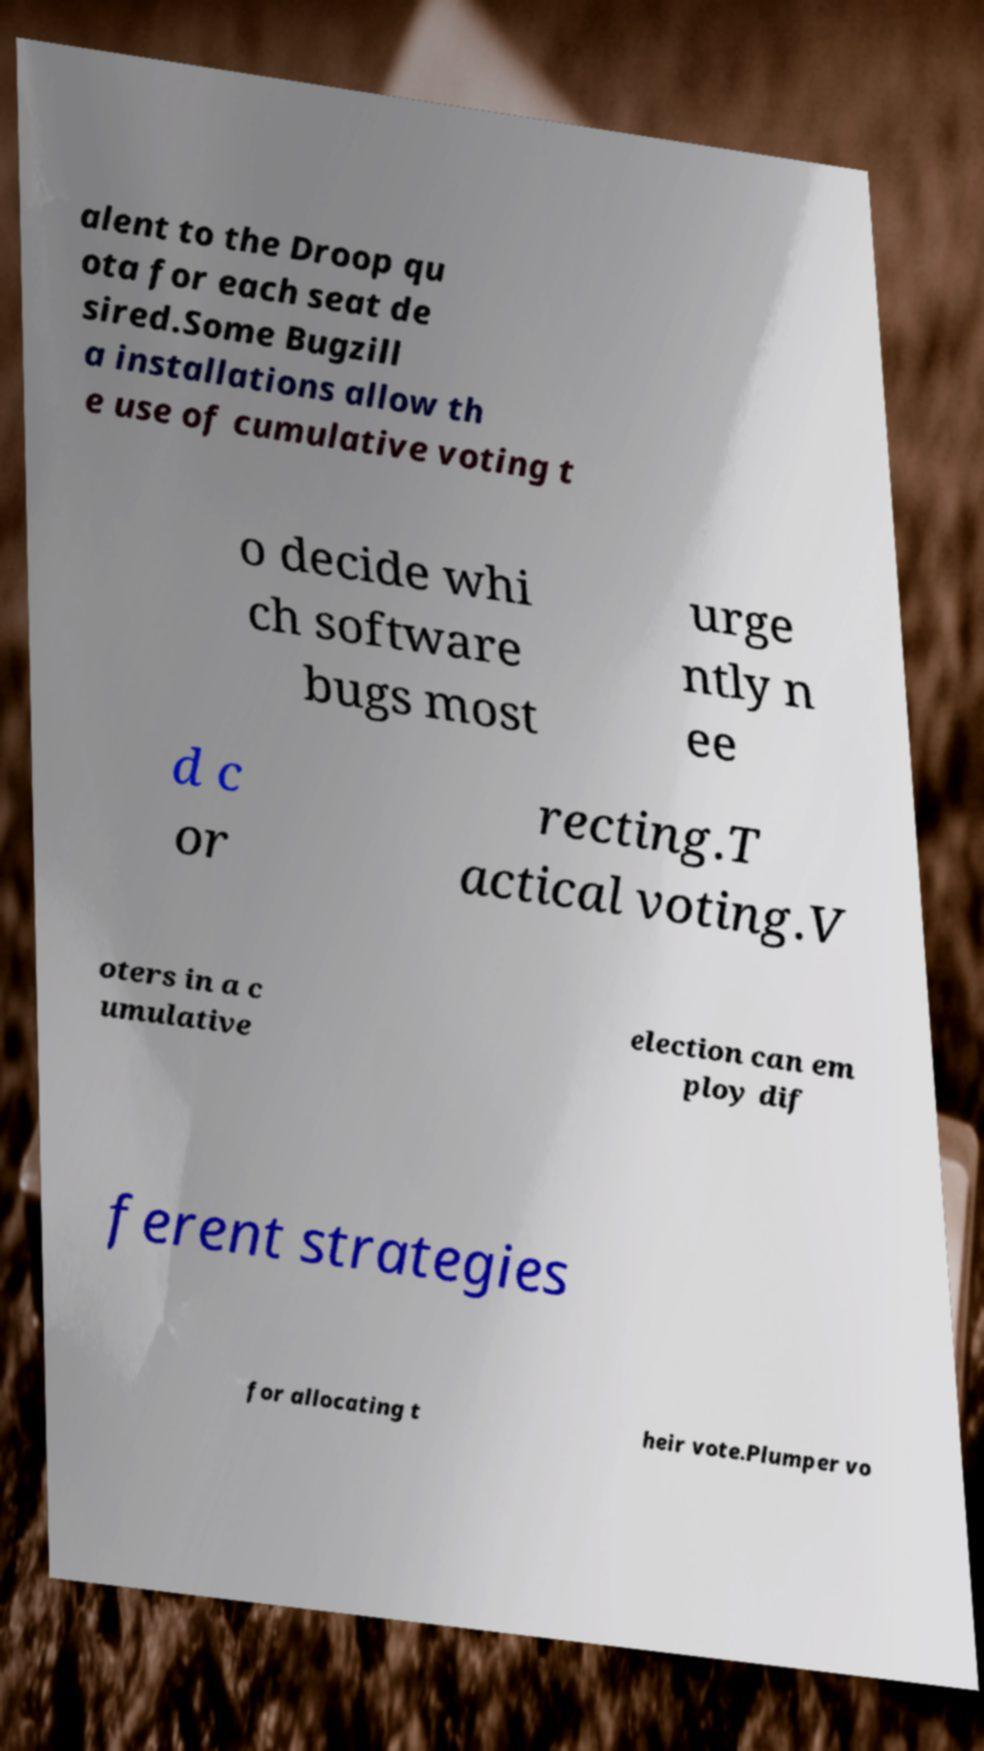Can you accurately transcribe the text from the provided image for me? alent to the Droop qu ota for each seat de sired.Some Bugzill a installations allow th e use of cumulative voting t o decide whi ch software bugs most urge ntly n ee d c or recting.T actical voting.V oters in a c umulative election can em ploy dif ferent strategies for allocating t heir vote.Plumper vo 